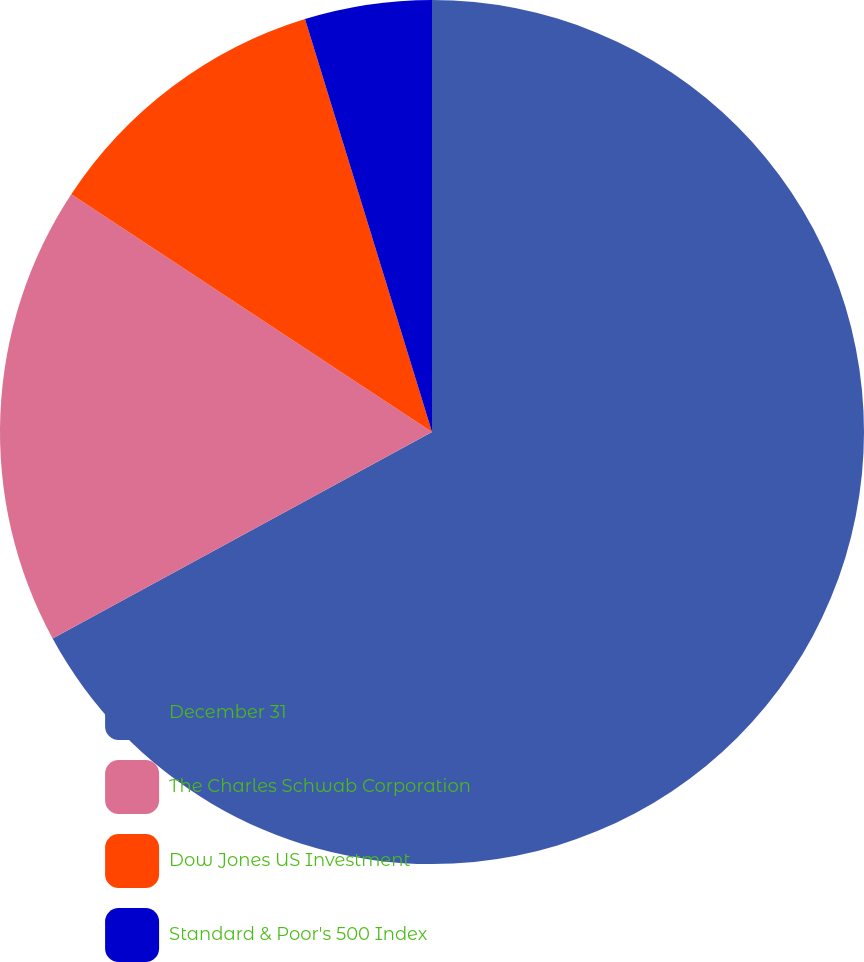<chart> <loc_0><loc_0><loc_500><loc_500><pie_chart><fcel>December 31<fcel>The Charles Schwab Corporation<fcel>Dow Jones US Investment<fcel>Standard & Poor's 500 Index<nl><fcel>67.07%<fcel>17.21%<fcel>10.98%<fcel>4.75%<nl></chart> 